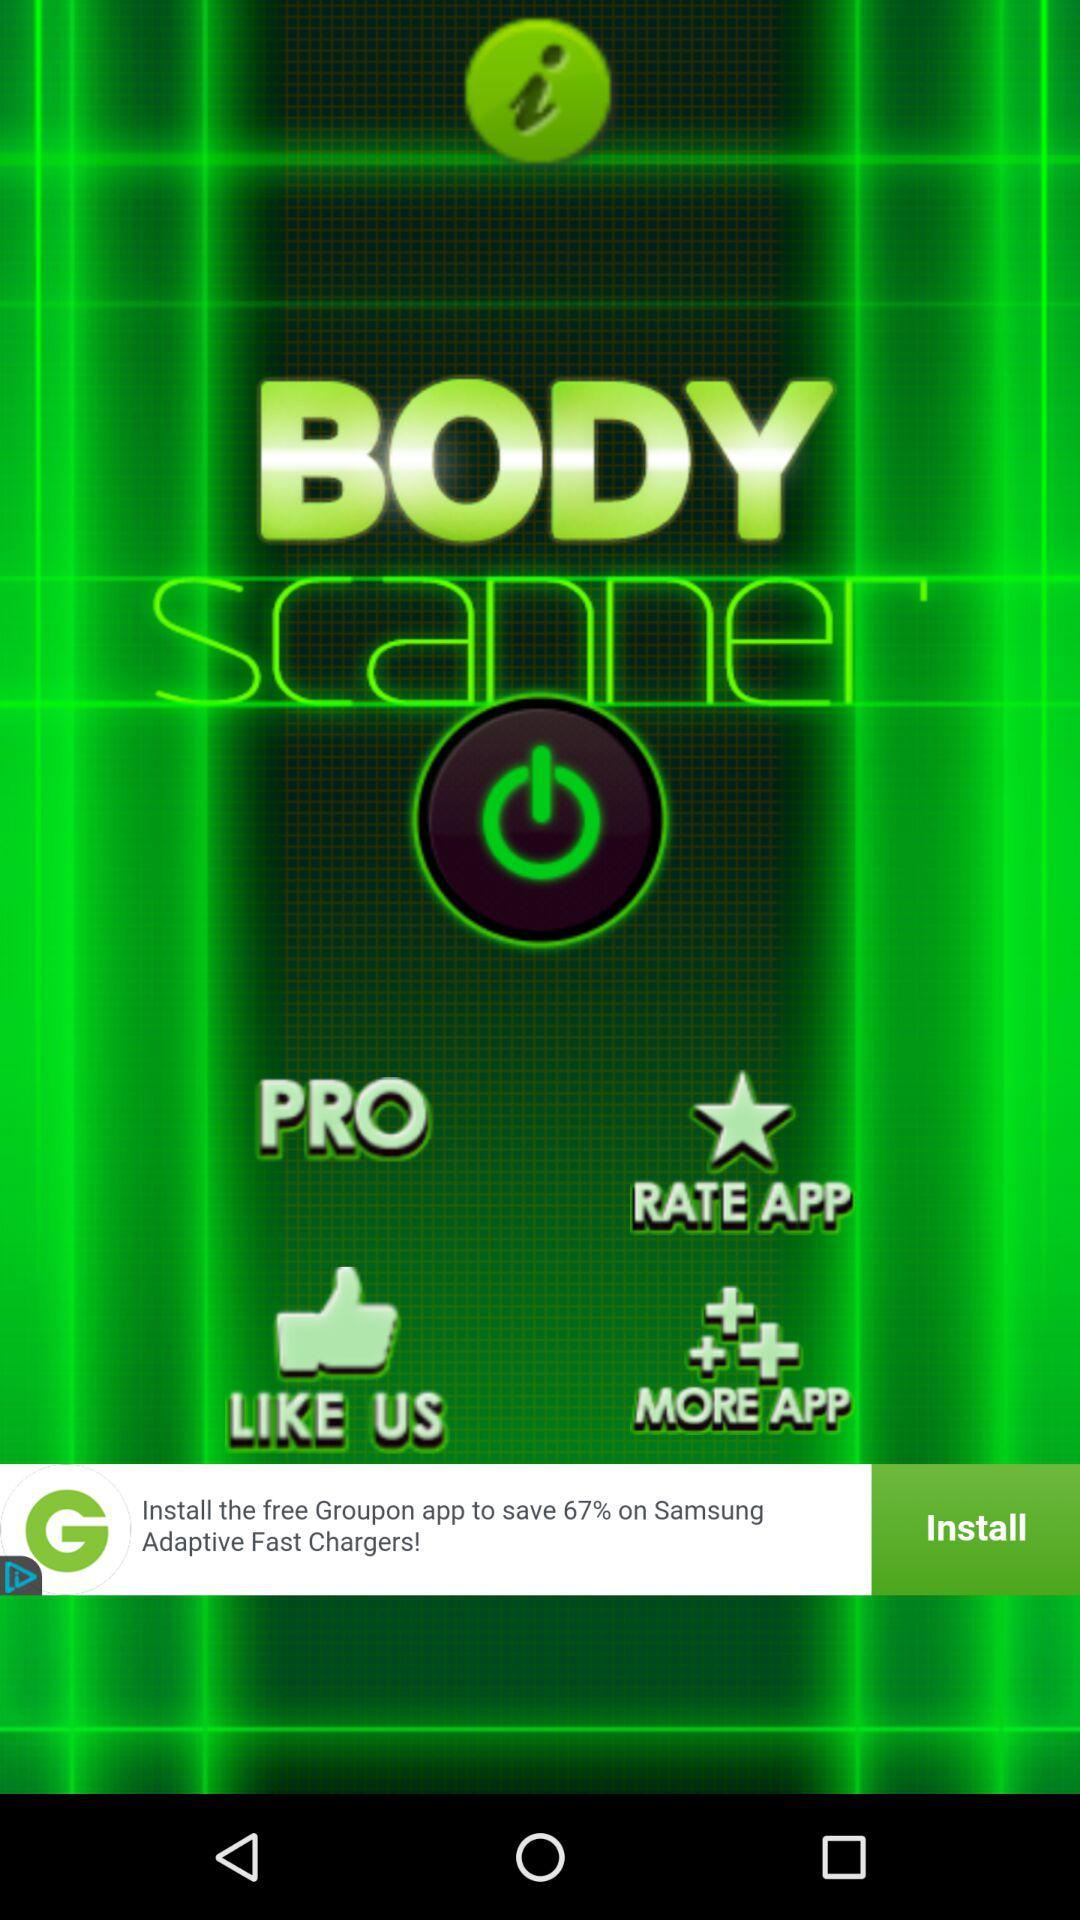What is the application name? The application name is "BODY scanner". 